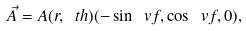<formula> <loc_0><loc_0><loc_500><loc_500>\vec { A } = A ( r , \ t h ) ( - \sin \ v f , \cos \ v f , 0 ) ,</formula> 